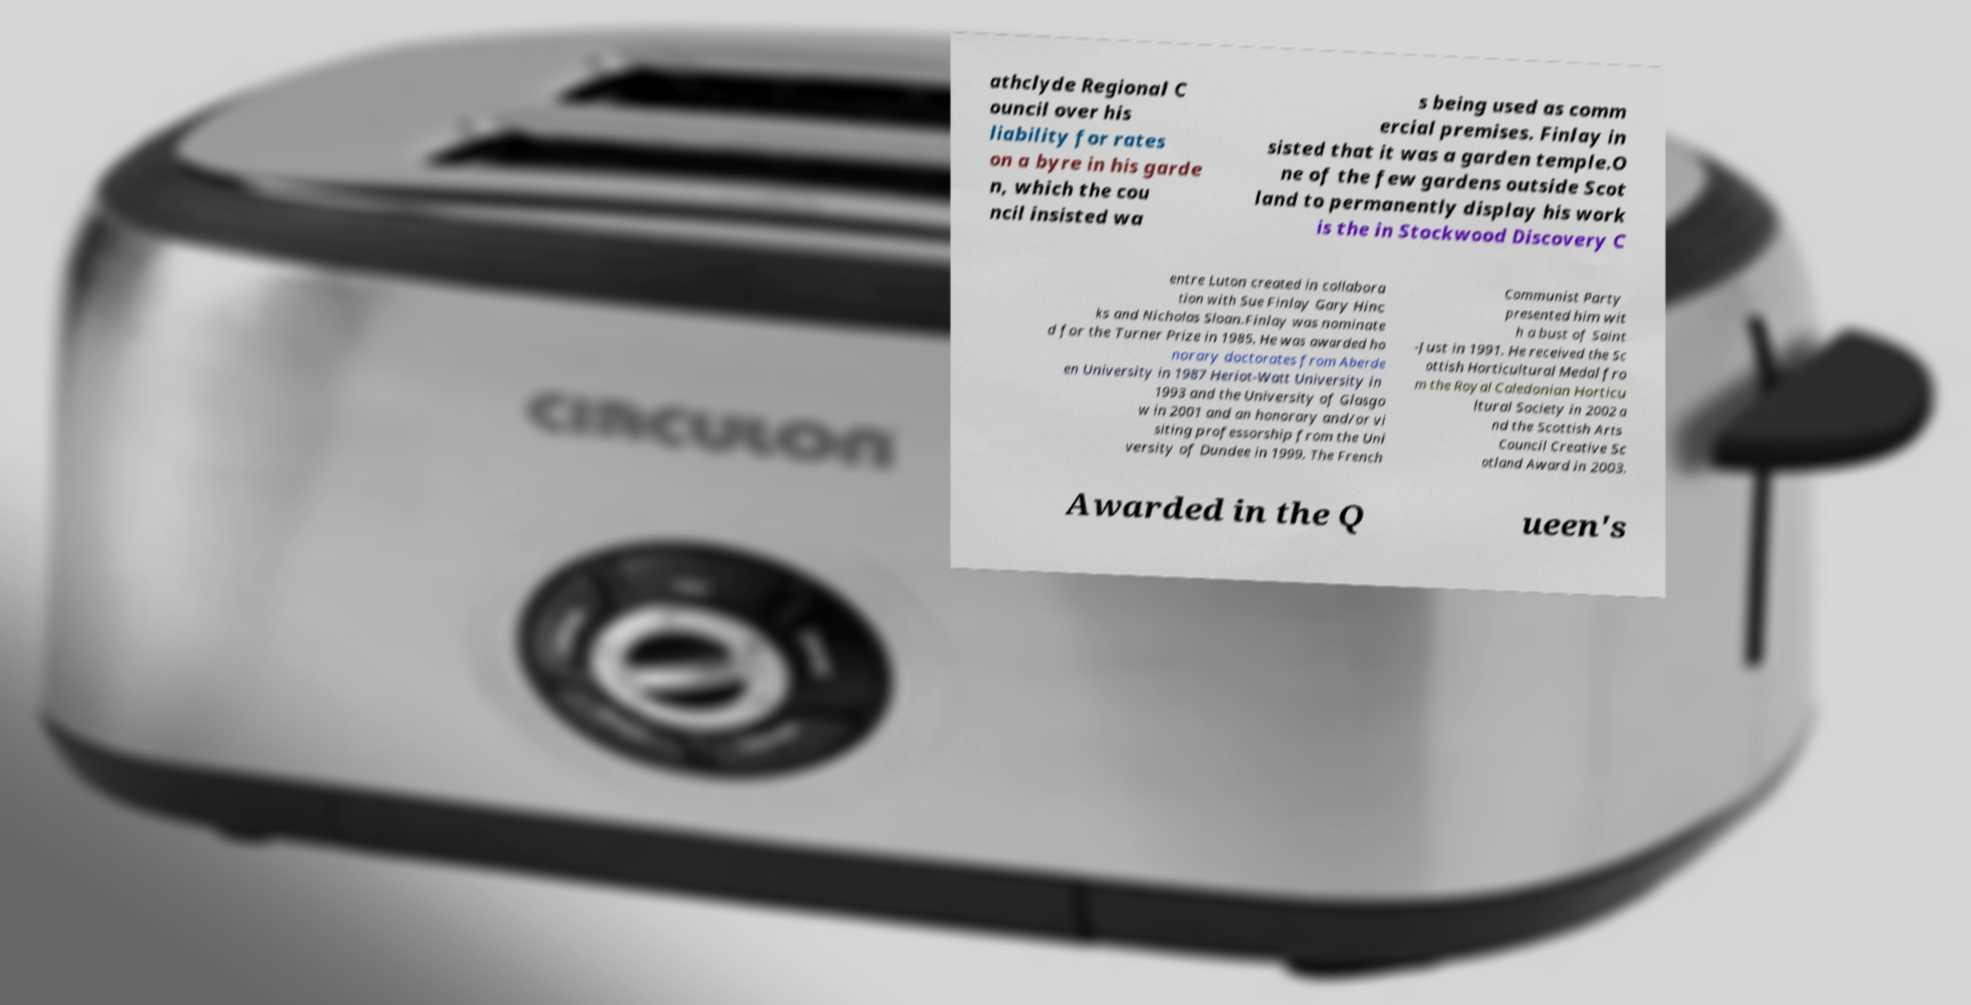I need the written content from this picture converted into text. Can you do that? athclyde Regional C ouncil over his liability for rates on a byre in his garde n, which the cou ncil insisted wa s being used as comm ercial premises. Finlay in sisted that it was a garden temple.O ne of the few gardens outside Scot land to permanently display his work is the in Stockwood Discovery C entre Luton created in collabora tion with Sue Finlay Gary Hinc ks and Nicholas Sloan.Finlay was nominate d for the Turner Prize in 1985. He was awarded ho norary doctorates from Aberde en University in 1987 Heriot-Watt University in 1993 and the University of Glasgo w in 2001 and an honorary and/or vi siting professorship from the Uni versity of Dundee in 1999. The French Communist Party presented him wit h a bust of Saint -Just in 1991. He received the Sc ottish Horticultural Medal fro m the Royal Caledonian Horticu ltural Society in 2002 a nd the Scottish Arts Council Creative Sc otland Award in 2003. Awarded in the Q ueen's 